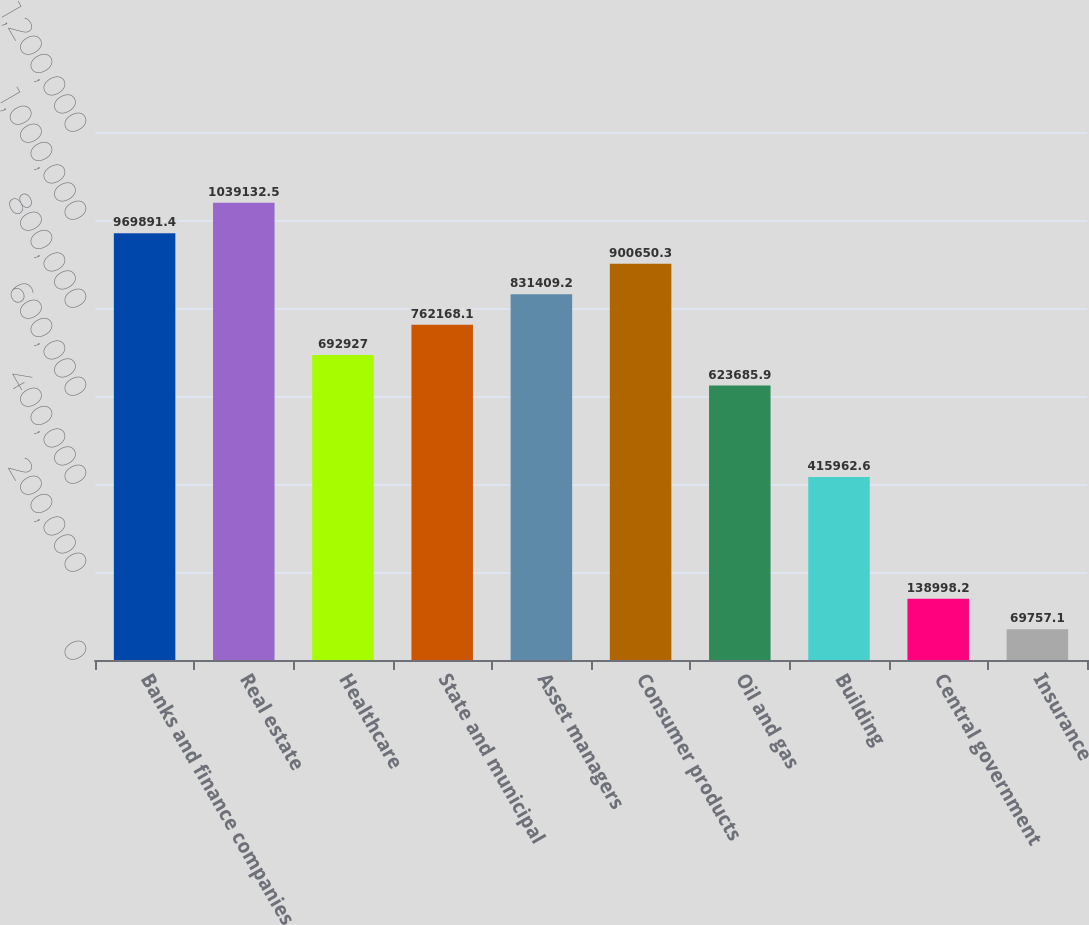Convert chart. <chart><loc_0><loc_0><loc_500><loc_500><bar_chart><fcel>Banks and finance companies<fcel>Real estate<fcel>Healthcare<fcel>State and municipal<fcel>Asset managers<fcel>Consumer products<fcel>Oil and gas<fcel>Building<fcel>Central government<fcel>Insurance<nl><fcel>969891<fcel>1.03913e+06<fcel>692927<fcel>762168<fcel>831409<fcel>900650<fcel>623686<fcel>415963<fcel>138998<fcel>69757.1<nl></chart> 